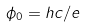<formula> <loc_0><loc_0><loc_500><loc_500>\phi _ { 0 } = h c / e</formula> 